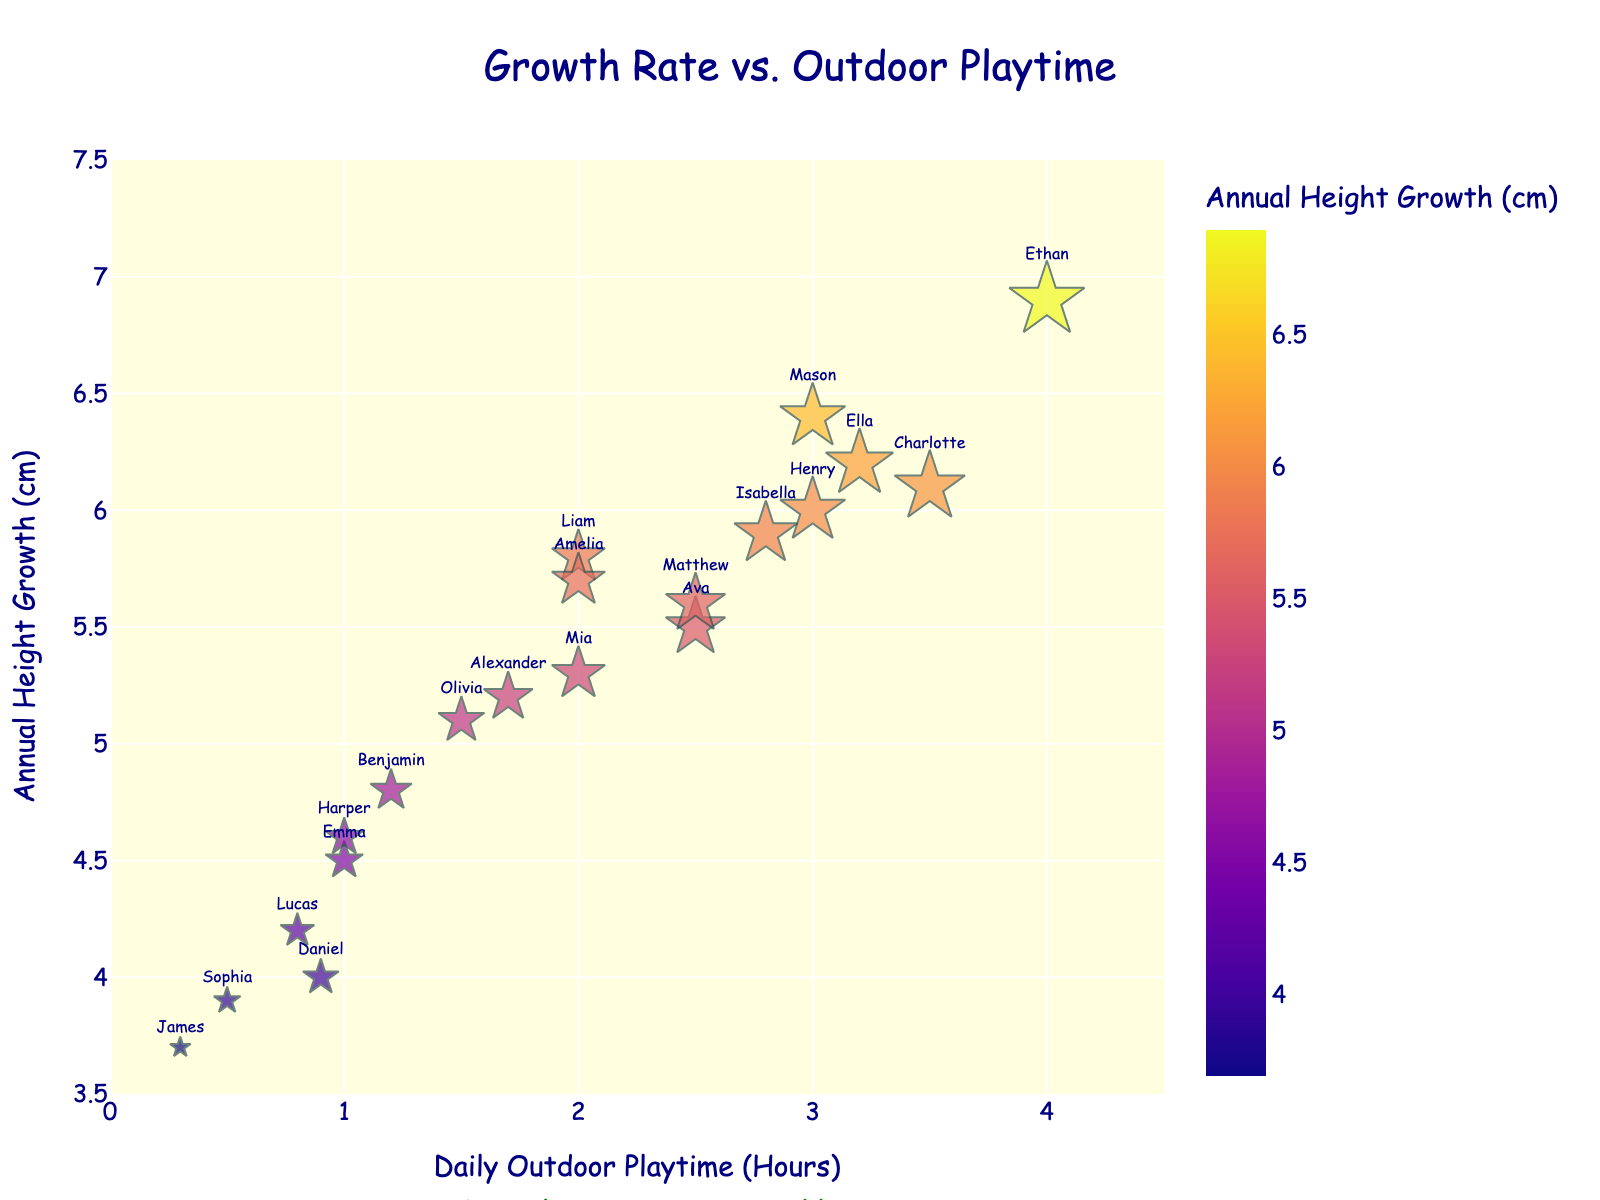What's the title of the figure? Look at the top center of the plot where the title is displayed.
Answer: Growth Rate vs. Outdoor Playtime How many children have their data points represented in the figure? Each child is represented by a star marker on the scatter plot. Count the number of these markers.
Answer: 19 What's the range of daily outdoor playtime hours shown on the x-axis? Check the x-axis at the bottom of the chart and look at the range it covers.
Answer: 0 to 4.5 hours Which child has the highest annual height growth? Find the data point with the highest position on the y-axis and note the child's name.
Answer: Ethan What's the color of the point representing the child with the lowest height growth? Look at the point near the lowest part of the y-axis and note its color.
Answer: Light blue How many children play outdoors for 2 hours daily? Find the data points directly above the label "2" on the x-axis and count them.
Answer: 2 (Liam and Amelia) What's the median value of annual height growth for children who play outdoors for 2 hours daily? Identify the children (Liam and Amelia) and find their annual height growth values (5.8 and 5.7). Median is the middle value in an ordered list.
Answer: 5.75 cm Who is taller, the child playing outdoors for 0.8 hours daily or the one for 3 hours? Compare the y-axis values for Lucas (0.8 hours) and Mason/Henry (3 hours).
Answer: Mason/Henry What is the relationship between outdoor playtime and height growth as indicated in the text annotation? Read the text annotation under the plot.
Answer: More playtime, more growth! What is the size difference between the markers representing 1.5 hours and 3.5 hours of outdoor playtime? Compare the size of the markers for Olivia (1.5 hours) and Charlotte (3.5 hours).
Answer: Charlotte's marker is larger 